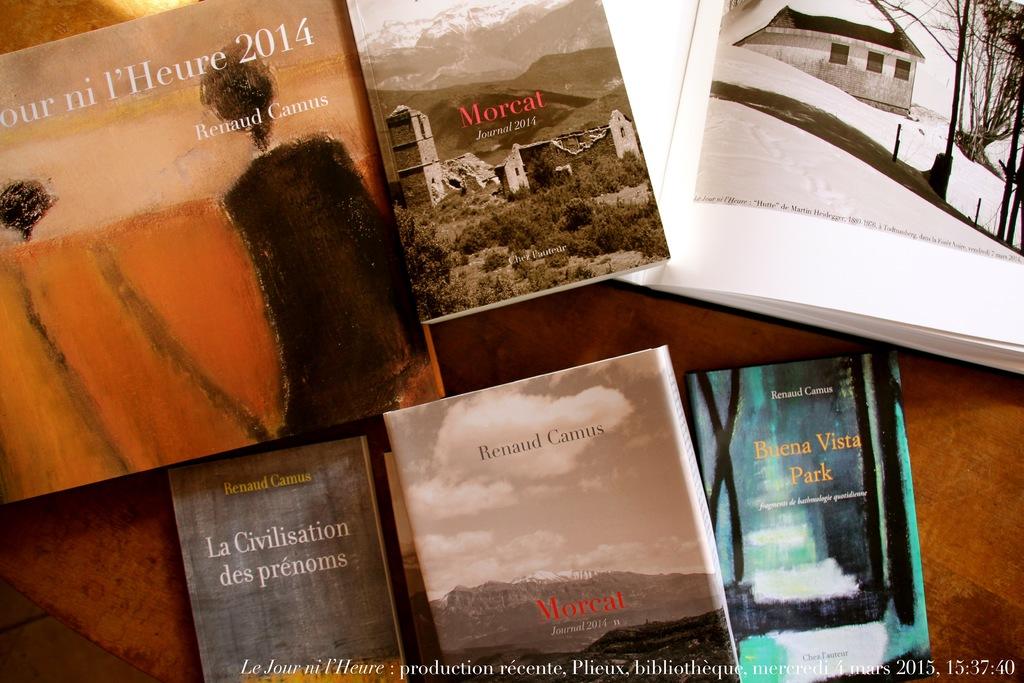What year was the first book written on the left?
Keep it short and to the point. 2014. 